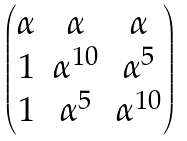Convert formula to latex. <formula><loc_0><loc_0><loc_500><loc_500>\begin{pmatrix} \alpha & \alpha & \alpha \\ 1 & \alpha ^ { 1 0 } & \alpha ^ { 5 } \\ 1 & \alpha ^ { 5 } & \alpha ^ { 1 0 } \end{pmatrix}</formula> 